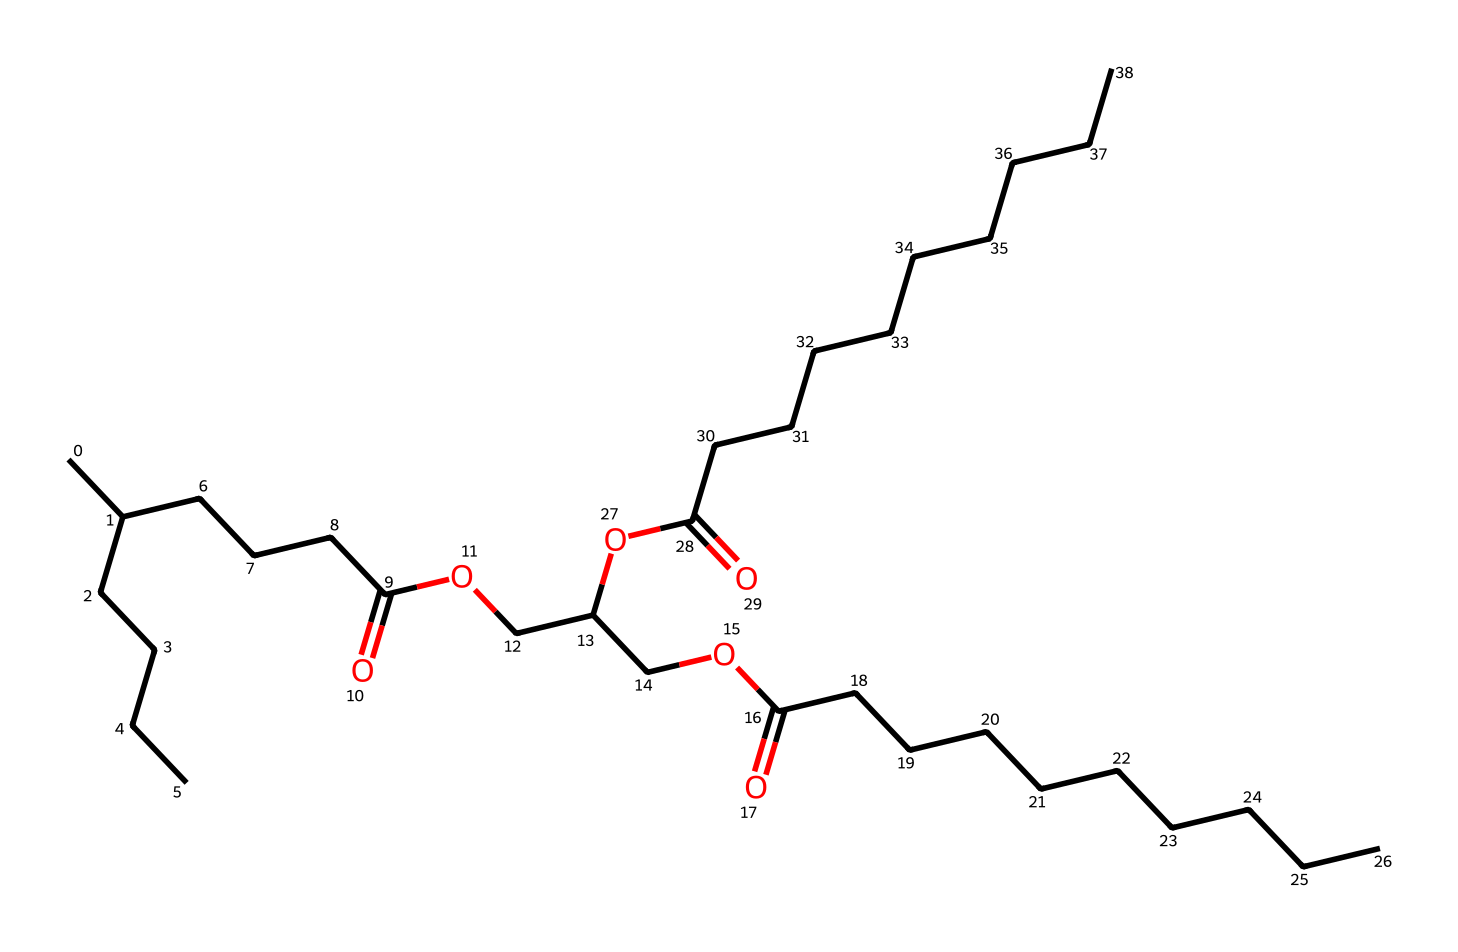What type of chemical compound is represented by the SMILES? The provided SMILES represents a lipid, specifically a triglyceride, which is a type of fat made up of glycerol and three fatty acids.
Answer: triglyceride How many ester bonds are present in this triglyceride? There are three ester bonds in this triglyceride, as each fatty acid is linked to the glycerol molecule through an ester bond. This can be observed in the structure where the carboxylic acid prepares to bond to the hydroxyl group of glycerol.
Answer: three What is the total number of carbon atoms in this molecule? By analyzing the SMILES representation, we can count the carbon atoms present in each part of the molecule. There are 30 carbon atoms in total, as derived from both the fatty acids and the glycerol backbone within the structure.
Answer: thirty What functional groups can be identified in this structure? The structure contains carboxylic acid functional groups (-COOH) from the fatty acids and ester functional groups (-COOR) where the fatty acids connect to the glycerol. These can be identified from the -O- connections and the carbonyl (C=O) components.
Answer: carboxylic acids and esters What is the primary biological role of triglycerides? The primary biological role of triglycerides is to store energy in the body. They serve as an efficient source of energy, as well as insulation and protection for organs. This is fundamental to their structure and function in living organisms.
Answer: energy storage What kind of fatty acids does this triglyceride contain? The SMILES suggests the presence of long-chain saturated fatty acids based on the long carbon chains seen in the structure. The absence of double bonds indicates that these are saturated fatty acids.
Answer: saturated fatty acids 